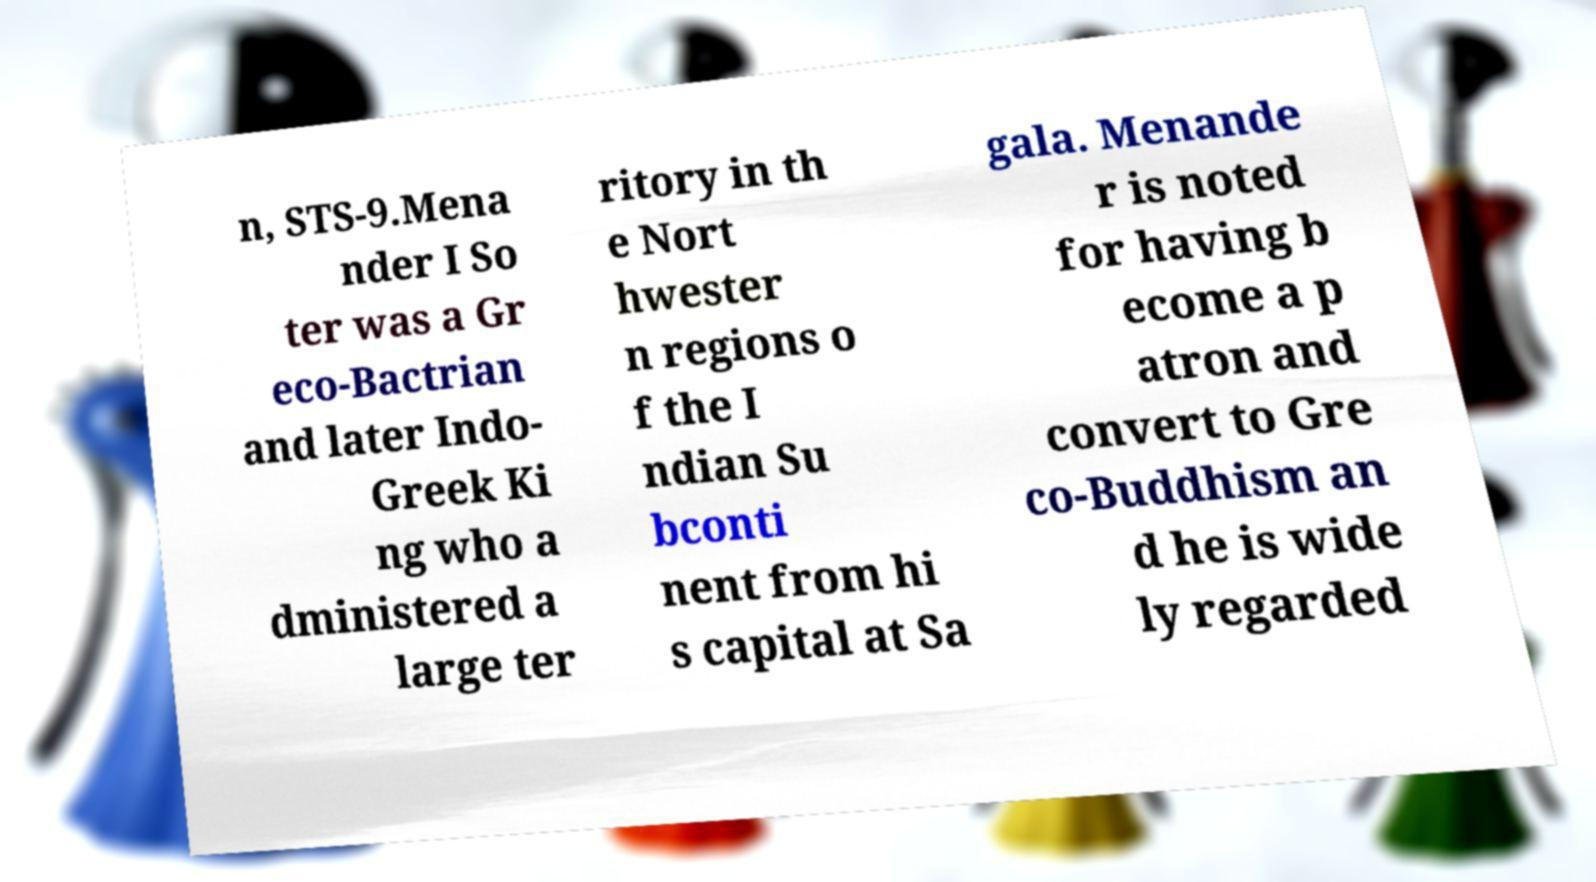There's text embedded in this image that I need extracted. Can you transcribe it verbatim? n, STS-9.Mena nder I So ter was a Gr eco-Bactrian and later Indo- Greek Ki ng who a dministered a large ter ritory in th e Nort hwester n regions o f the I ndian Su bconti nent from hi s capital at Sa gala. Menande r is noted for having b ecome a p atron and convert to Gre co-Buddhism an d he is wide ly regarded 